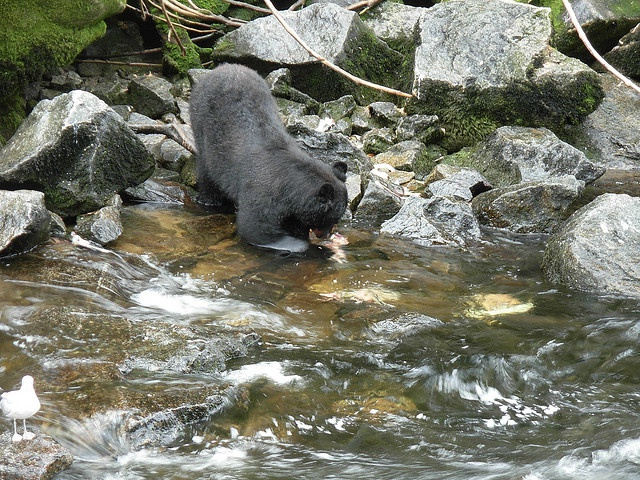Describe the objects in this image and their specific colors. I can see bear in darkgreen, gray, black, darkgray, and purple tones and bird in darkgreen, white, darkgray, and gray tones in this image. 